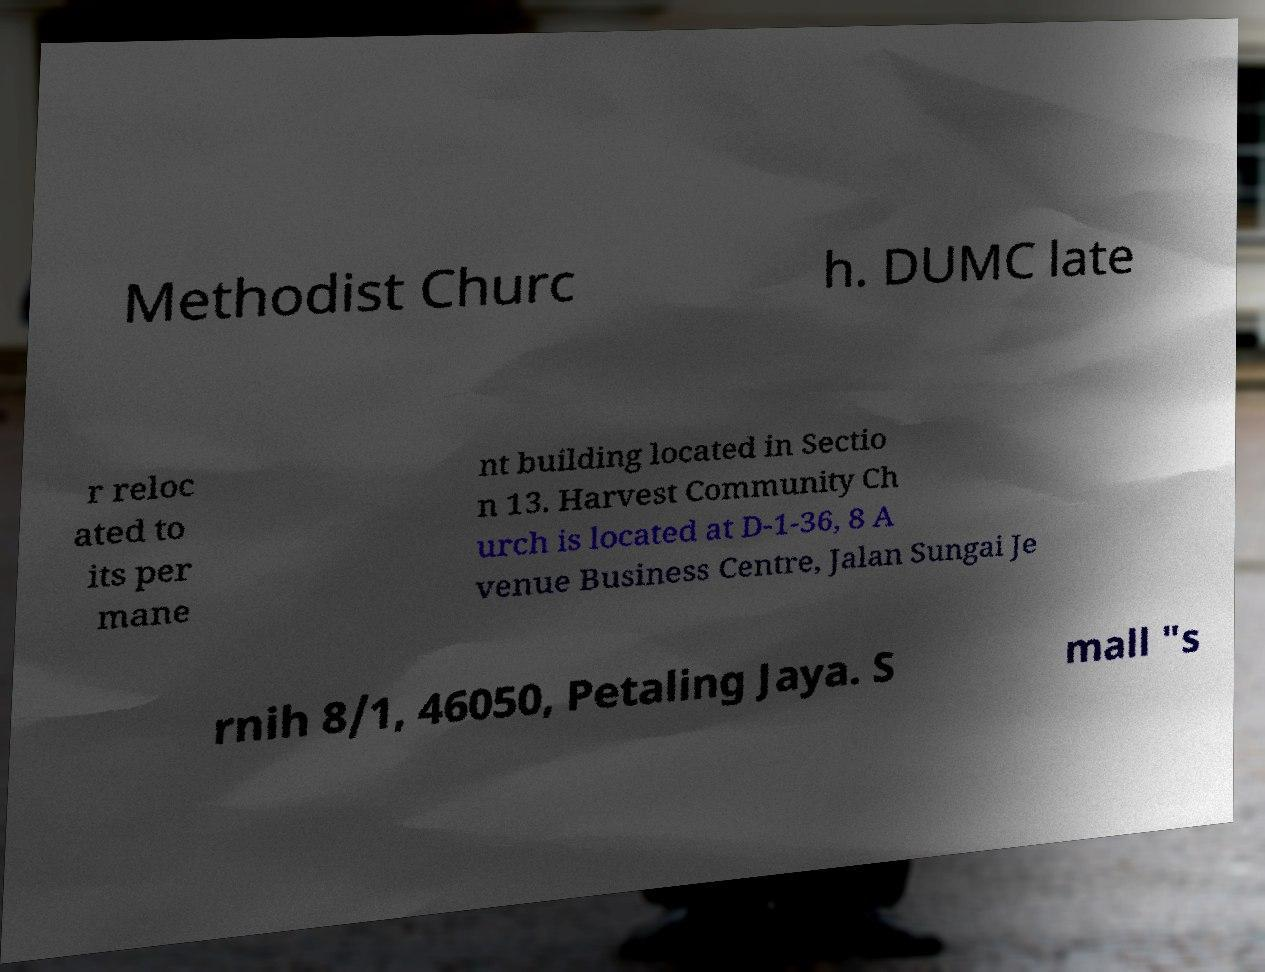Could you extract and type out the text from this image? Methodist Churc h. DUMC late r reloc ated to its per mane nt building located in Sectio n 13. Harvest Community Ch urch is located at D-1-36, 8 A venue Business Centre, Jalan Sungai Je rnih 8/1, 46050, Petaling Jaya. S mall "s 